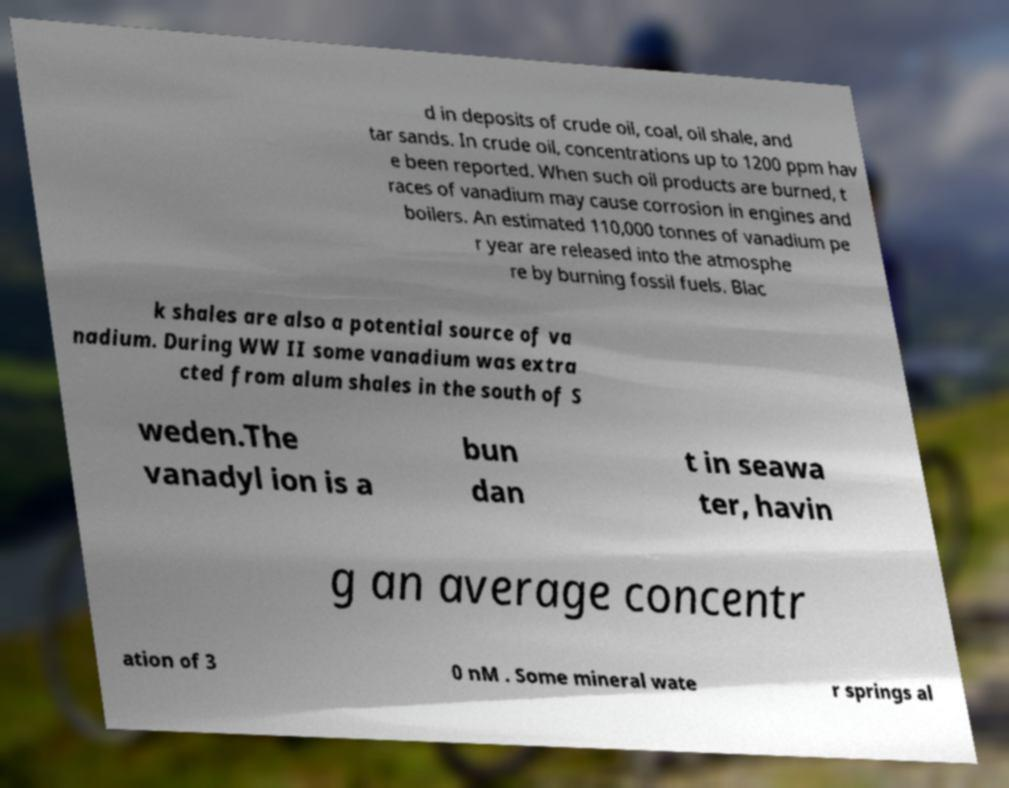Can you accurately transcribe the text from the provided image for me? d in deposits of crude oil, coal, oil shale, and tar sands. In crude oil, concentrations up to 1200 ppm hav e been reported. When such oil products are burned, t races of vanadium may cause corrosion in engines and boilers. An estimated 110,000 tonnes of vanadium pe r year are released into the atmosphe re by burning fossil fuels. Blac k shales are also a potential source of va nadium. During WW II some vanadium was extra cted from alum shales in the south of S weden.The vanadyl ion is a bun dan t in seawa ter, havin g an average concentr ation of 3 0 nM . Some mineral wate r springs al 